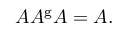Convert formula to latex. <formula><loc_0><loc_0><loc_500><loc_500>A A ^ { g } A = A .</formula> 